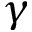Convert formula to latex. <formula><loc_0><loc_0><loc_500><loc_500>\gamma</formula> 